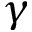Convert formula to latex. <formula><loc_0><loc_0><loc_500><loc_500>\gamma</formula> 